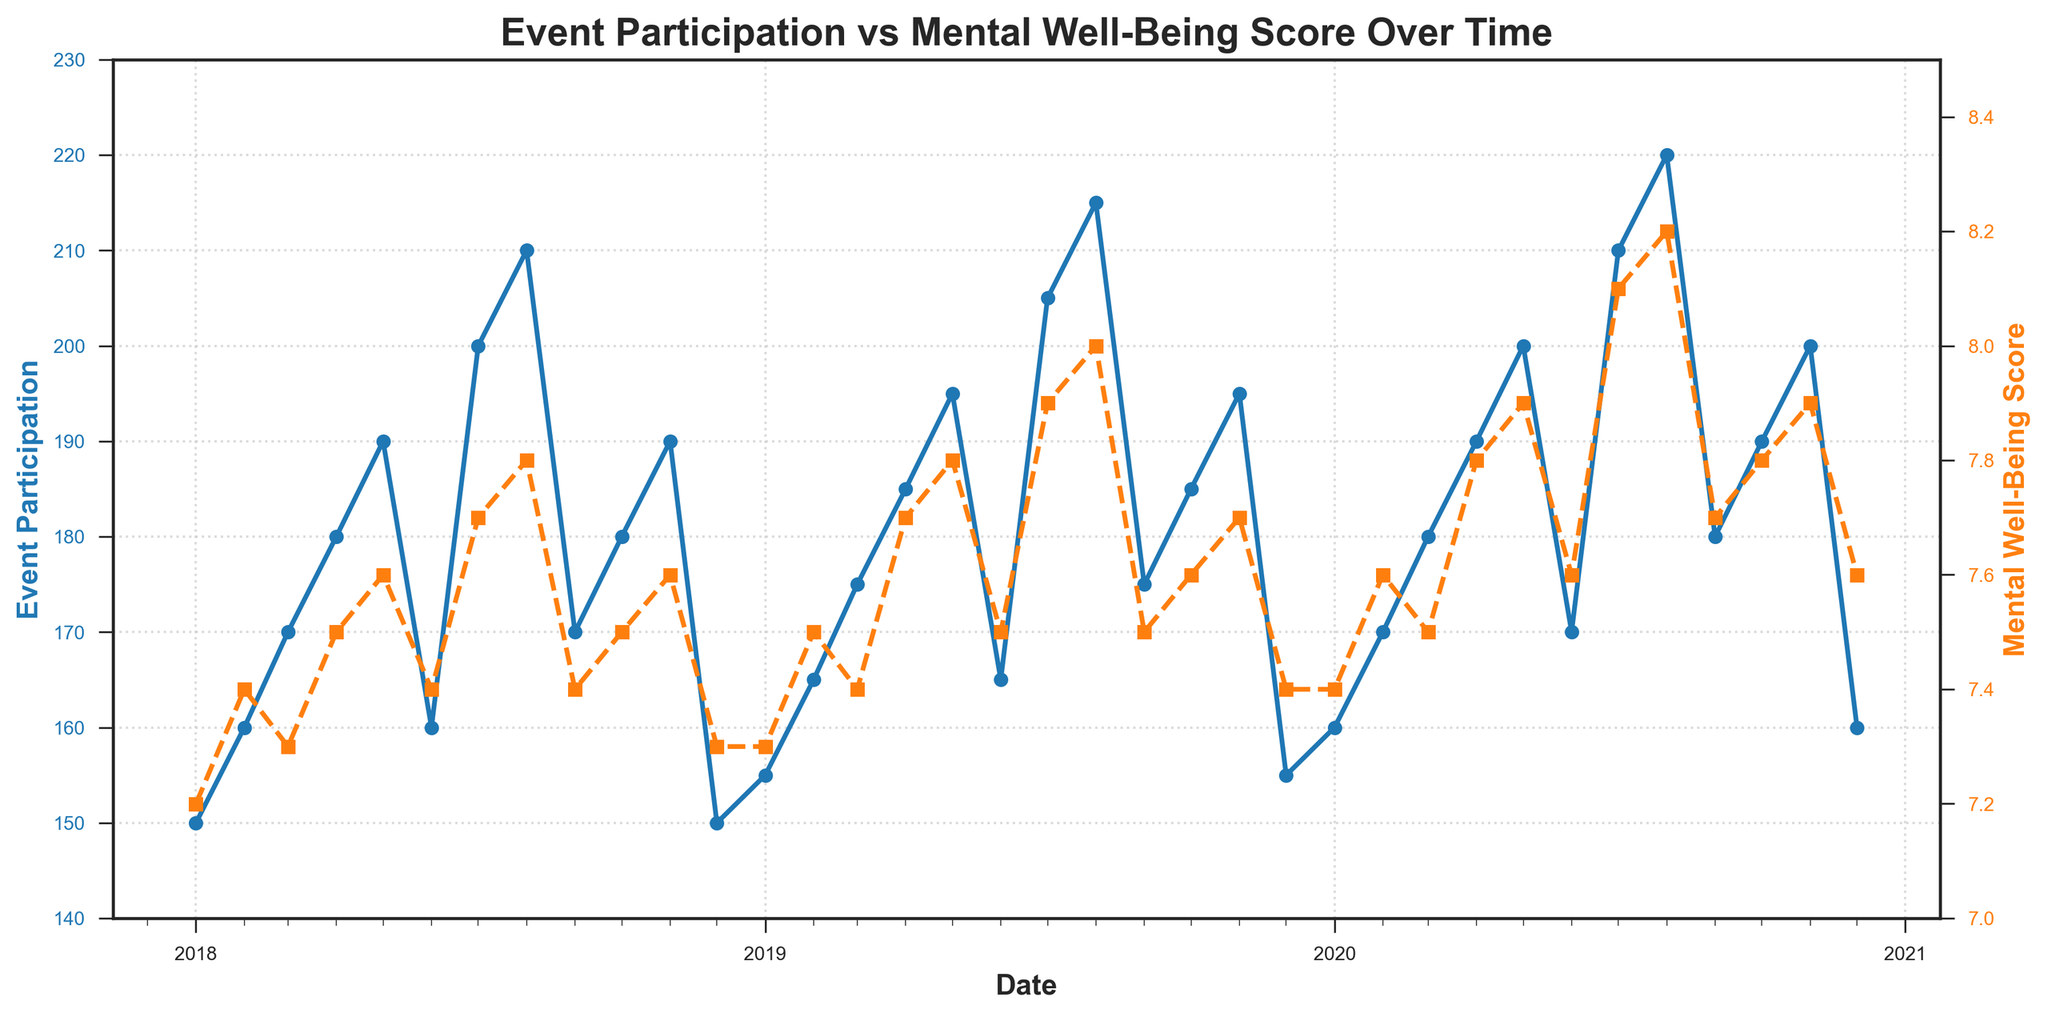What are the two variables being compared in the plot? The plot compares 'Event Participation' represented by the blue line and 'Mental Well-Being Score' represented by the orange line.
Answer: Event Participation and Mental Well-Being Score What is the range of values for Event Participation? By examining the y-axis on the left side of the plot, we can see that Event Participation ranges from 140 to 230.
Answer: 140 to 230 How does Event Participation change from January to July in 2018? Observing the blue line for the period January to July 2018, Event Participation increases from 150 in January to 200 in July.
Answer: It increases from 150 to 200 What is the difference in Mental Well-Being Score between August 2019 and December 2019? The Mental Well-Being Score in August 2019 is 8.0, and in December 2019, it is 7.4. The difference is calculated as 8.0 - 7.4 = 0.6.
Answer: 0.6 Which month in 2020 had the highest Event Participation? By inspecting the blue line in 2020, August shows the highest Event Participation at 220.
Answer: August 2020 Is there a pattern observed in Event Participation and Mental Well-Being Score over the three years? Both Event Participation and Mental Well-Being Score generally show an increasing trend from 2018 to 2020, with some seasonal fluctuations.
Answer: Increasing trend During which period did the Mental Well-Being Score reach its peak, and what was the value? The Mental Well-Being Score peaks in August 2020, as seen in the orange line, with a value of 8.2.
Answer: August 2020, 8.2 Is there any month when Event Participation is the same for all three years? January in 2018, 2019, and 2020 shows similar Event Participation values; 150, 155, and 160 respectively, with only slight differences.
Answer: No exact same values How do Event Participation and Mental Well-Being Score compare in December 2018, 2019, and 2020? In December 2018, Event Participation is 150, and the Score is 7.3. In December 2019, Participation is 155, and the Score is 7.4. In December 2020, Participation is 160, and the Score is 7.6. Both indicators show slight increases each year.
Answer: Both increased each year What seasonal trends do you notice for Mental Well-Being Score? The orange line shows that Mental Well-Being Scores tend to peak around July and August each year and dip around December or January.
Answer: Peaks in July-August, dips in December-January 